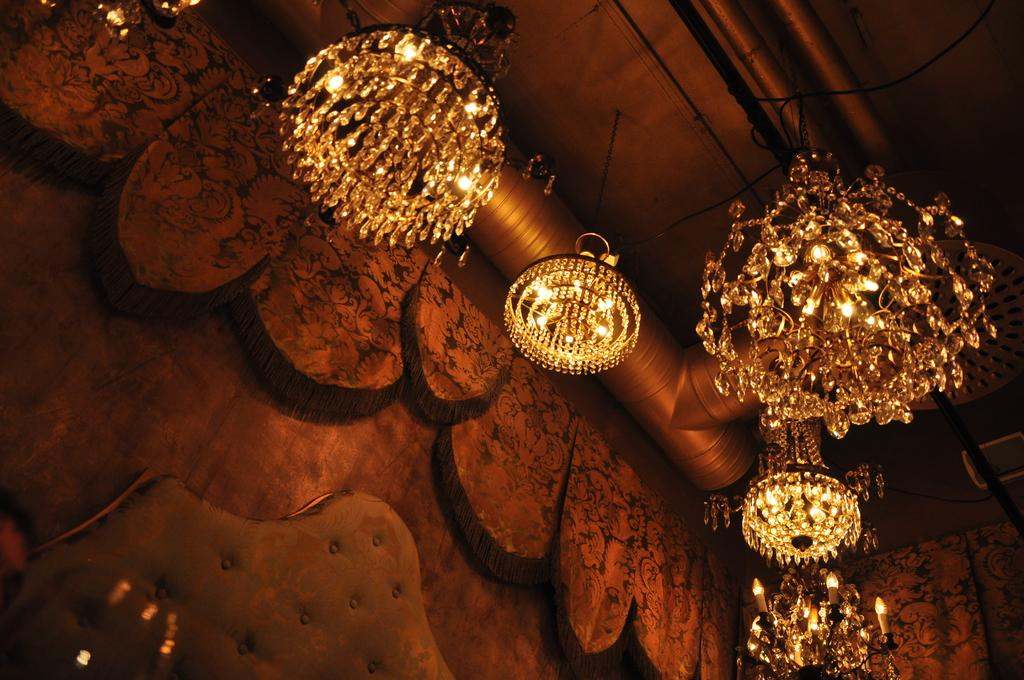What type of lighting is present in the image? There are ceiling lights in the image. What type of structure can be seen in the image? There is a wall in the image. What type of objects are present in the image for decorative purposes? Decorative items are present in the image. What type of plumbing feature can be seen in the image? There is a pipe in the image. What type of support structures are visible in the image? Poles are visible in the image. Can you tell me how many deer are present in the image? There are no deer present in the image. What type of son is visible in the image? There is no son present in the image. 